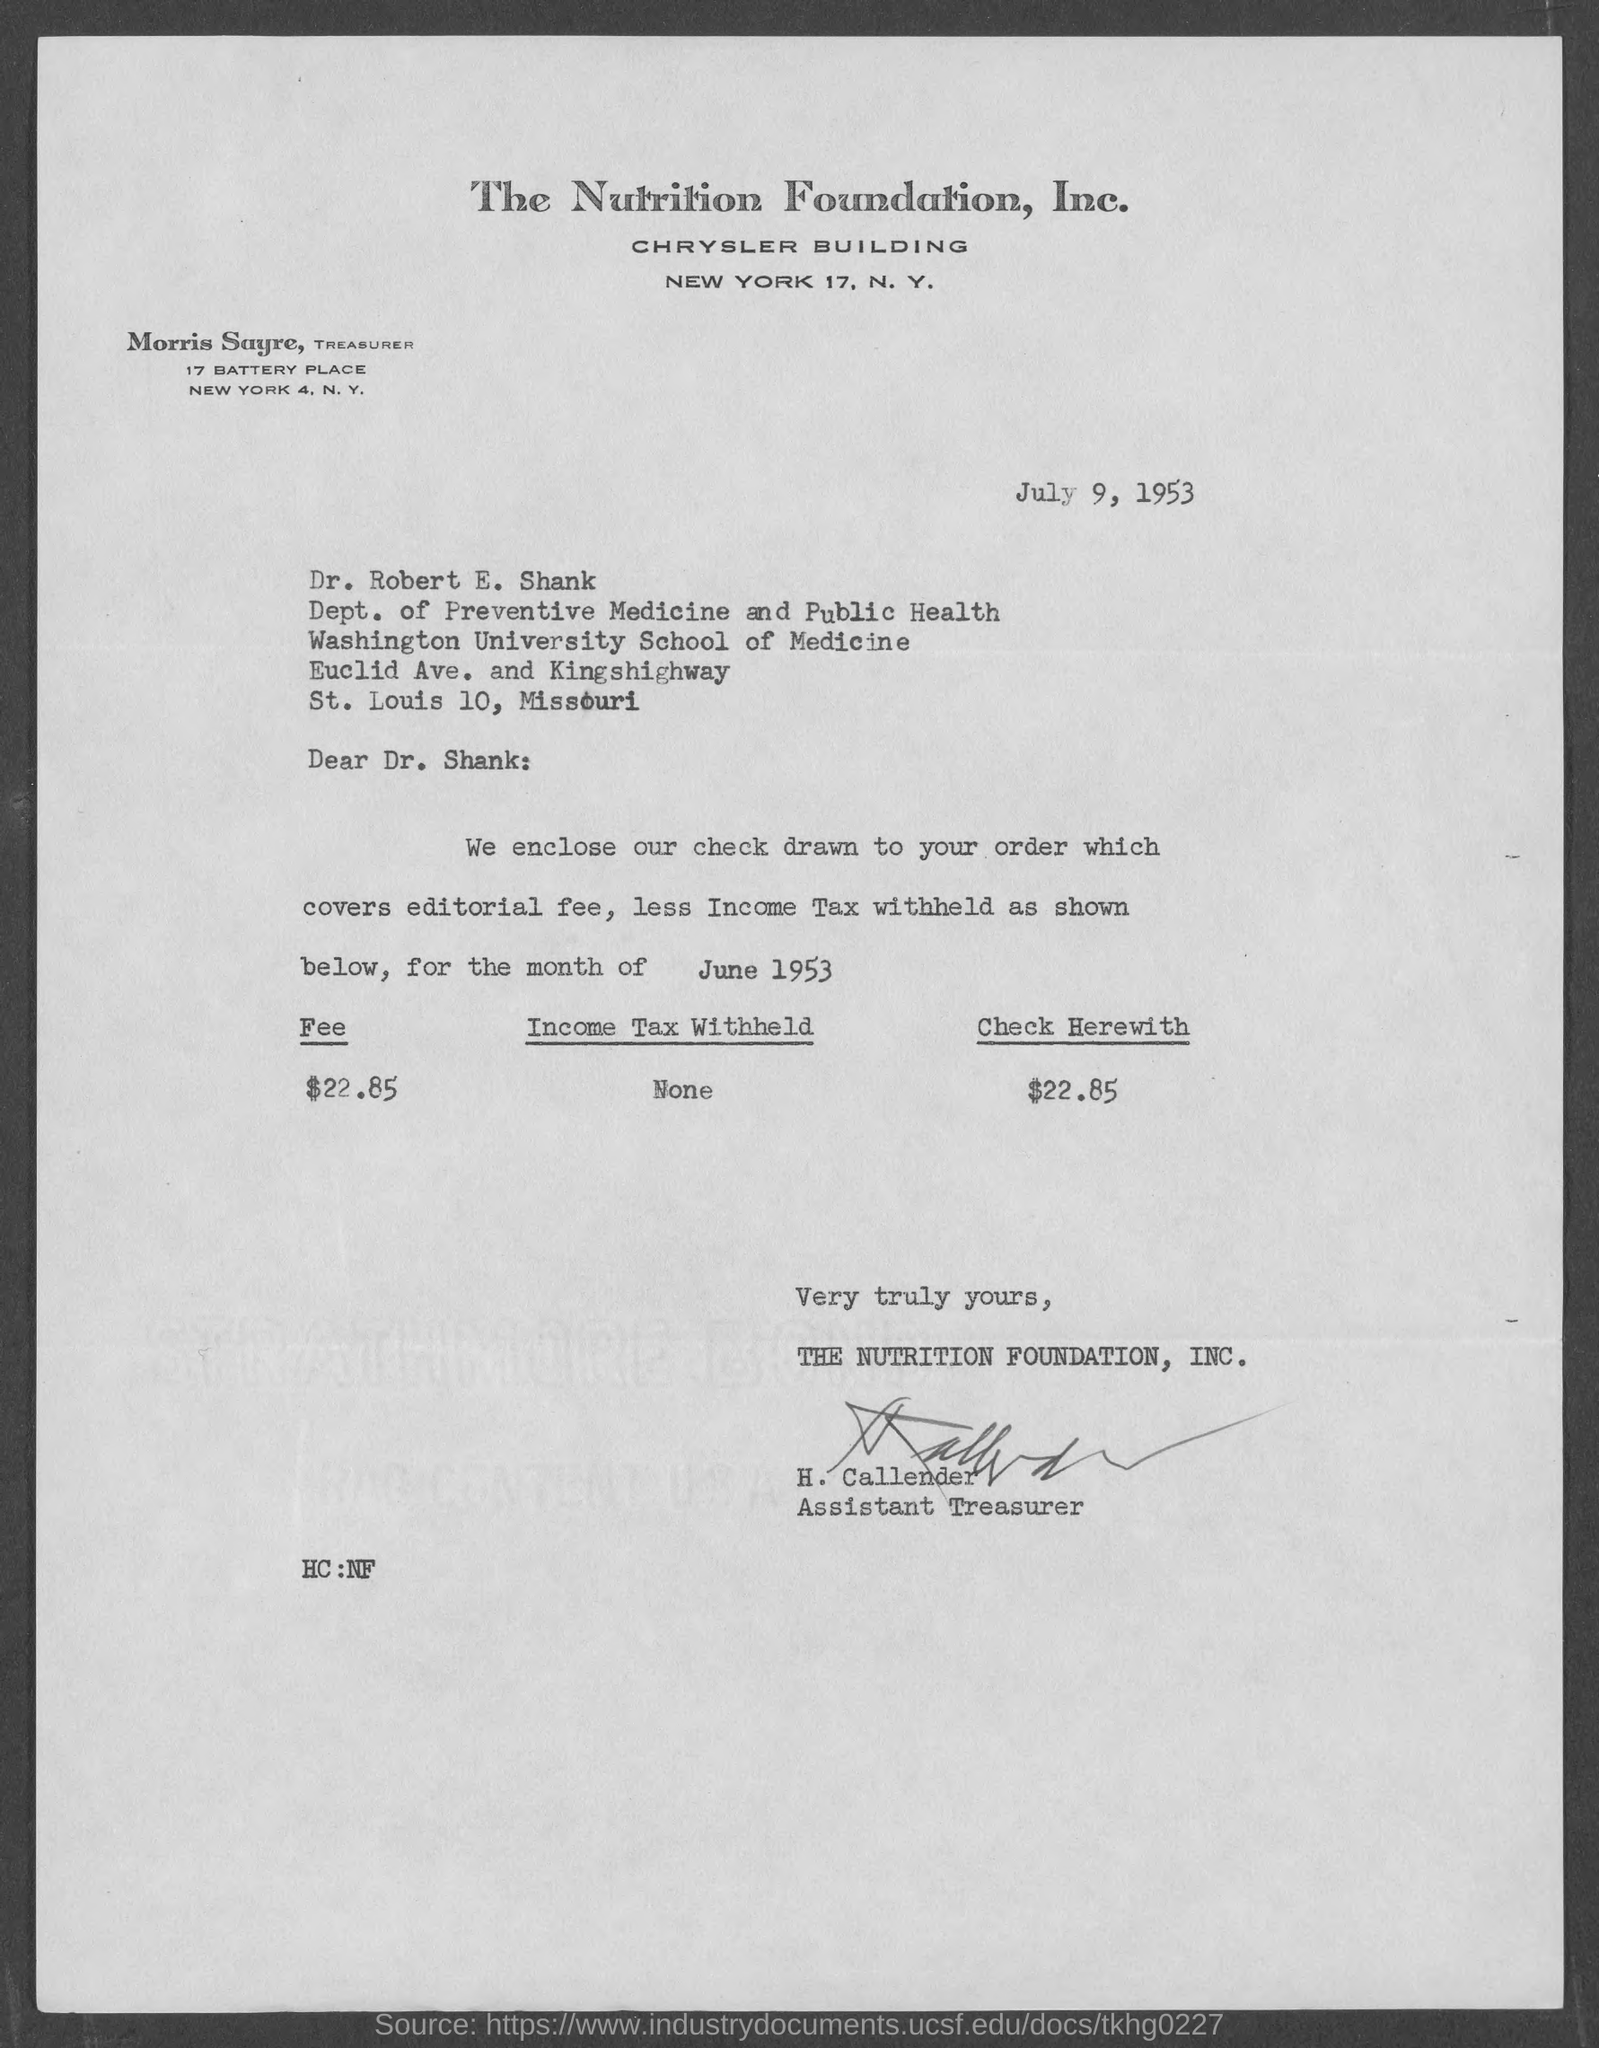What is the date on the document?
Your answer should be very brief. July 9, 1953. To Whom is this letter addressed to?
Provide a succinct answer. Dr. Robert E. Shank. Who is this letter from?
Offer a terse response. Assistant Treasurer. What is the Fee for the month of June 1953?
Give a very brief answer. 22.85. 